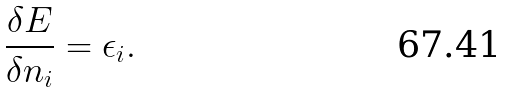<formula> <loc_0><loc_0><loc_500><loc_500>\frac { \delta E } { \delta n _ { i } } = \epsilon _ { i } .</formula> 